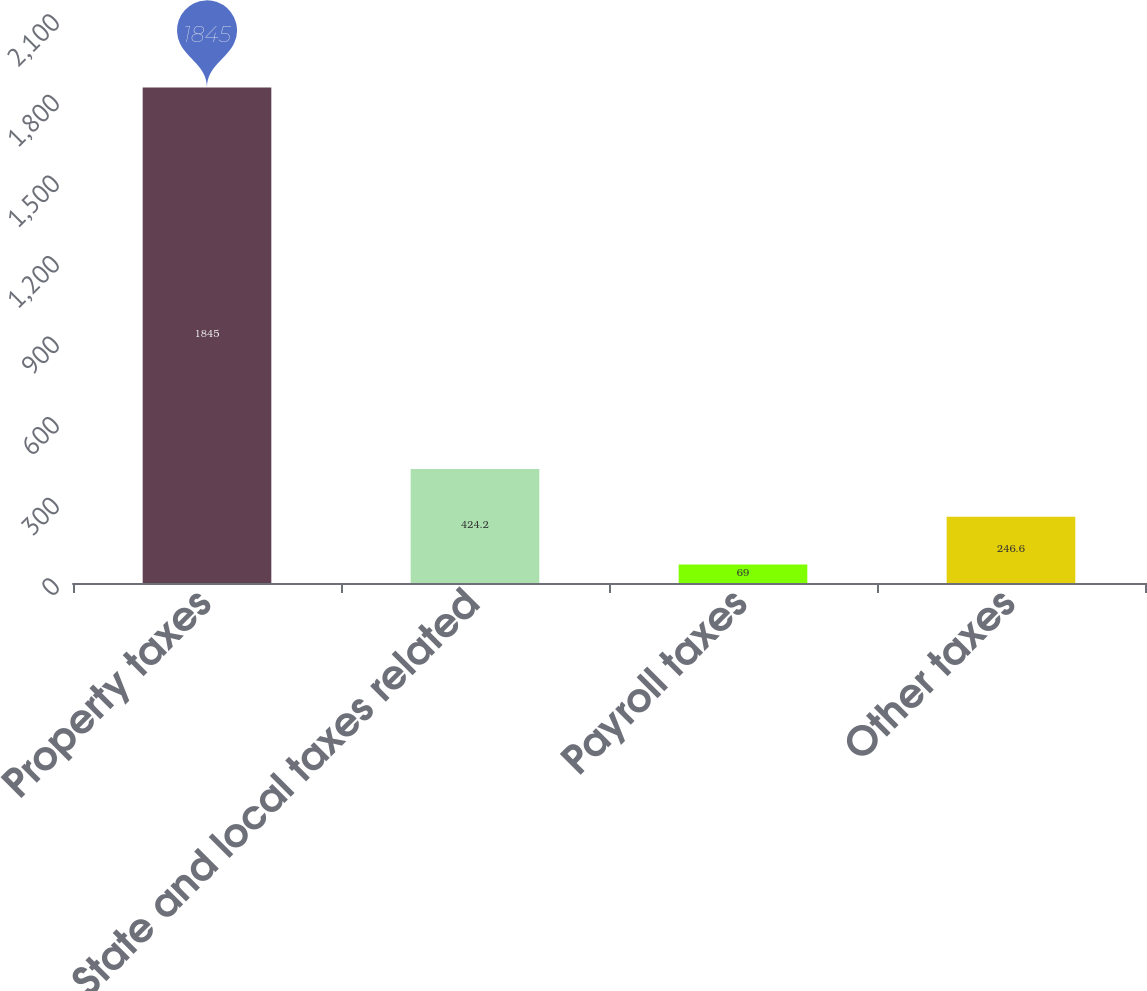<chart> <loc_0><loc_0><loc_500><loc_500><bar_chart><fcel>Property taxes<fcel>State and local taxes related<fcel>Payroll taxes<fcel>Other taxes<nl><fcel>1845<fcel>424.2<fcel>69<fcel>246.6<nl></chart> 